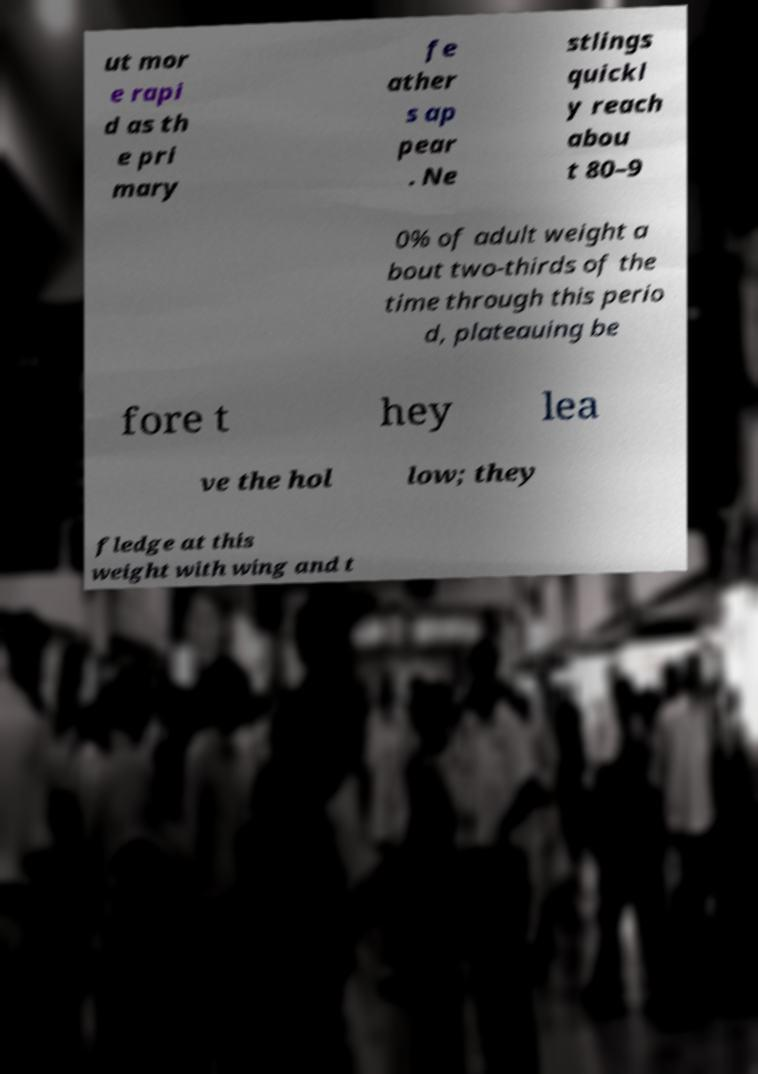Could you extract and type out the text from this image? ut mor e rapi d as th e pri mary fe ather s ap pear . Ne stlings quickl y reach abou t 80–9 0% of adult weight a bout two-thirds of the time through this perio d, plateauing be fore t hey lea ve the hol low; they fledge at this weight with wing and t 